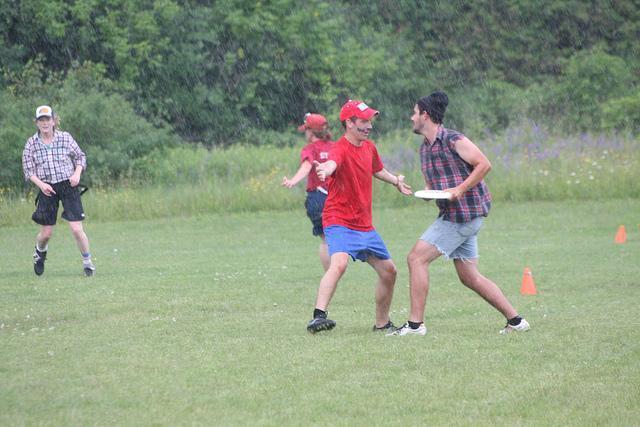How many cones can you see?
Give a very brief answer. 2. How many red hats are there?
Give a very brief answer. 2. How many people are visible?
Give a very brief answer. 4. 